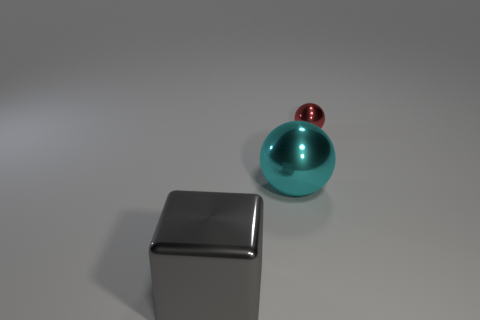Can you tell me about the lighting in this image? The image shows a soft, diffused lighting that casts gentle shadows on the surface. The light source seems to be positioned above the objects, providing an even illumination that highlights the curvature of the balls and the angular shape of the box. Is the surface they are on reflective? Yes, the surface underneath the objects has a reflective quality, which can be observed from the subtle reflections of the balls and the box. This suggests that the surface could be a polished, smooth material, such as glass or a coated metal. 